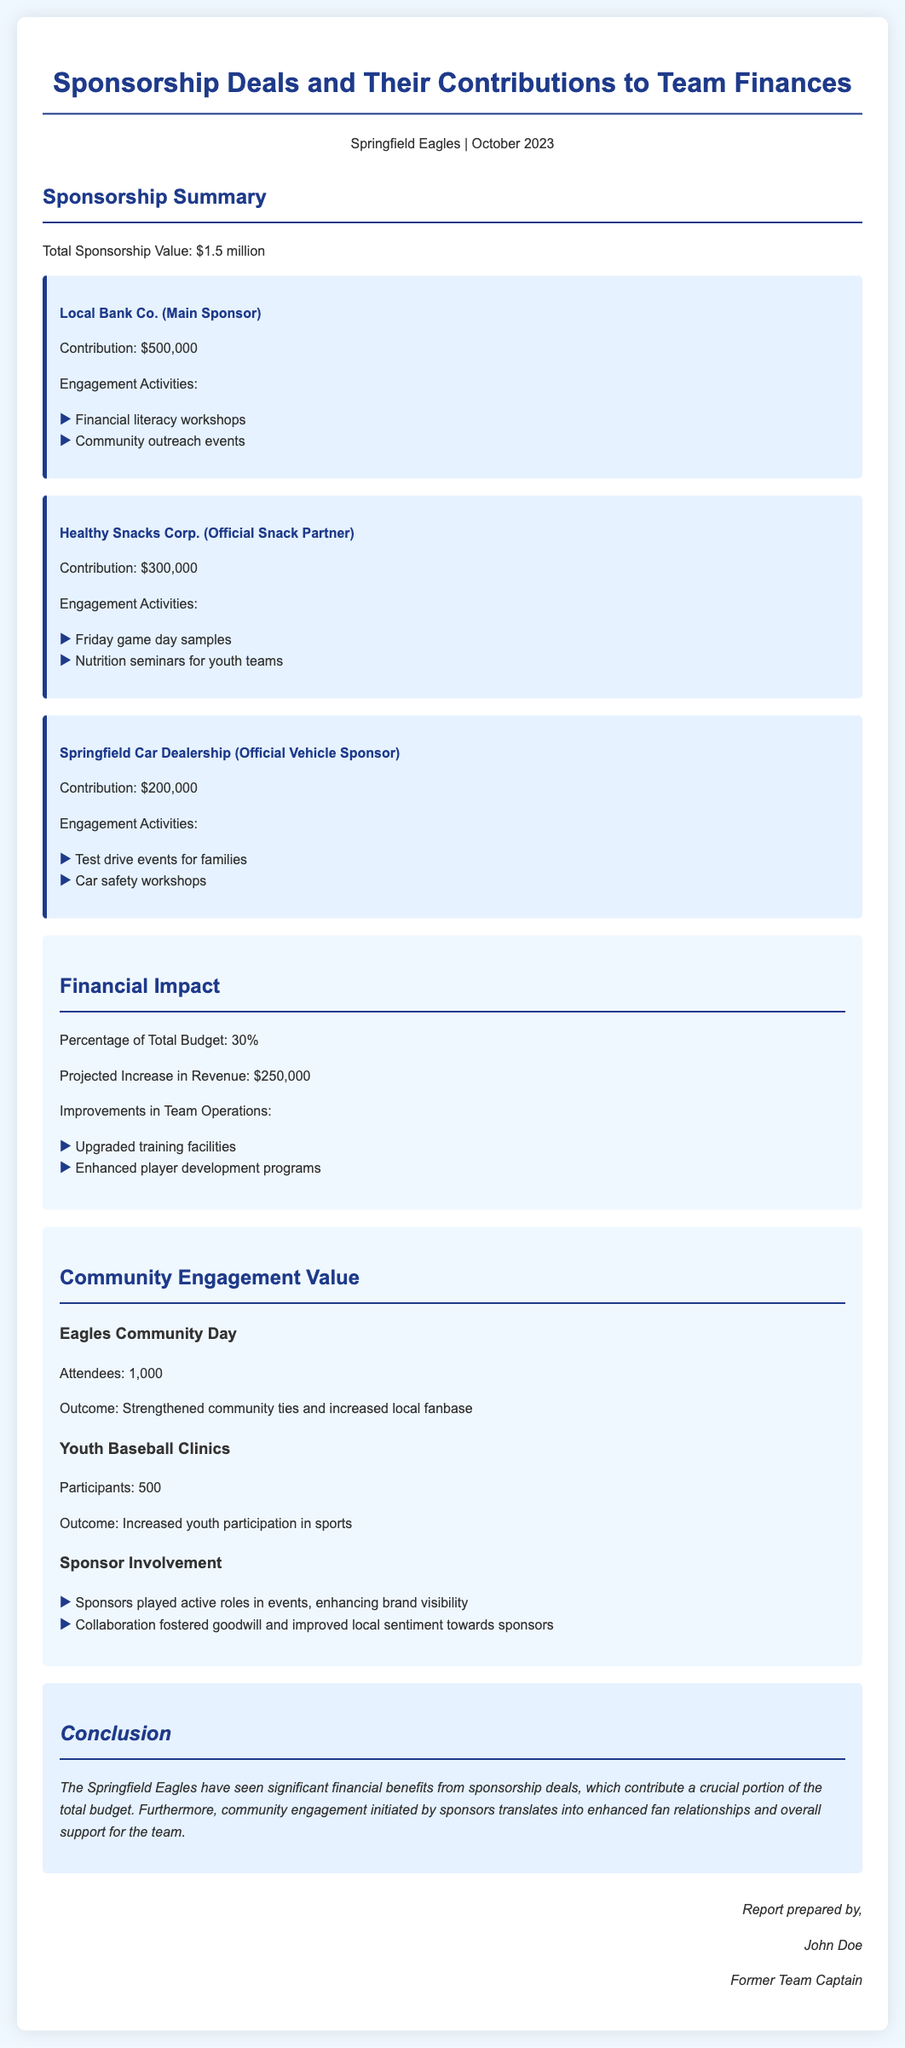What is the total sponsorship value? The total sponsorship value is mentioned in the document as $1.5 million.
Answer: $1.5 million Who is the main sponsor? The main sponsor is identified in the document as Local Bank Co.
Answer: Local Bank Co What is the contribution from Healthy Snacks Corp.? The contribution from Healthy Snacks Corp. is specified as $300,000.
Answer: $300,000 What percentage of the total budget do sponsorships represent? The document states that sponsorships represent 30% of the total budget.
Answer: 30% How many attendees were at Eagles Community Day? The document indicates that there were 1,000 attendees at Eagles Community Day.
Answer: 1,000 What was the outcome of youth baseball clinics? The outcome of youth baseball clinics is noted as increased youth participation in sports.
Answer: Increased youth participation in sports What is the projected increase in revenue from sponsorships? The projected increase in revenue from sponsorships is mentioned as $250,000.
Answer: $250,000 What type of activities did sponsors engage in? Sponsors engaged in activities like community outreach events and workshops.
Answer: Community outreach events and workshops Who prepared the report? The report is prepared by John Doe, as stated at the bottom of the document.
Answer: John Doe 